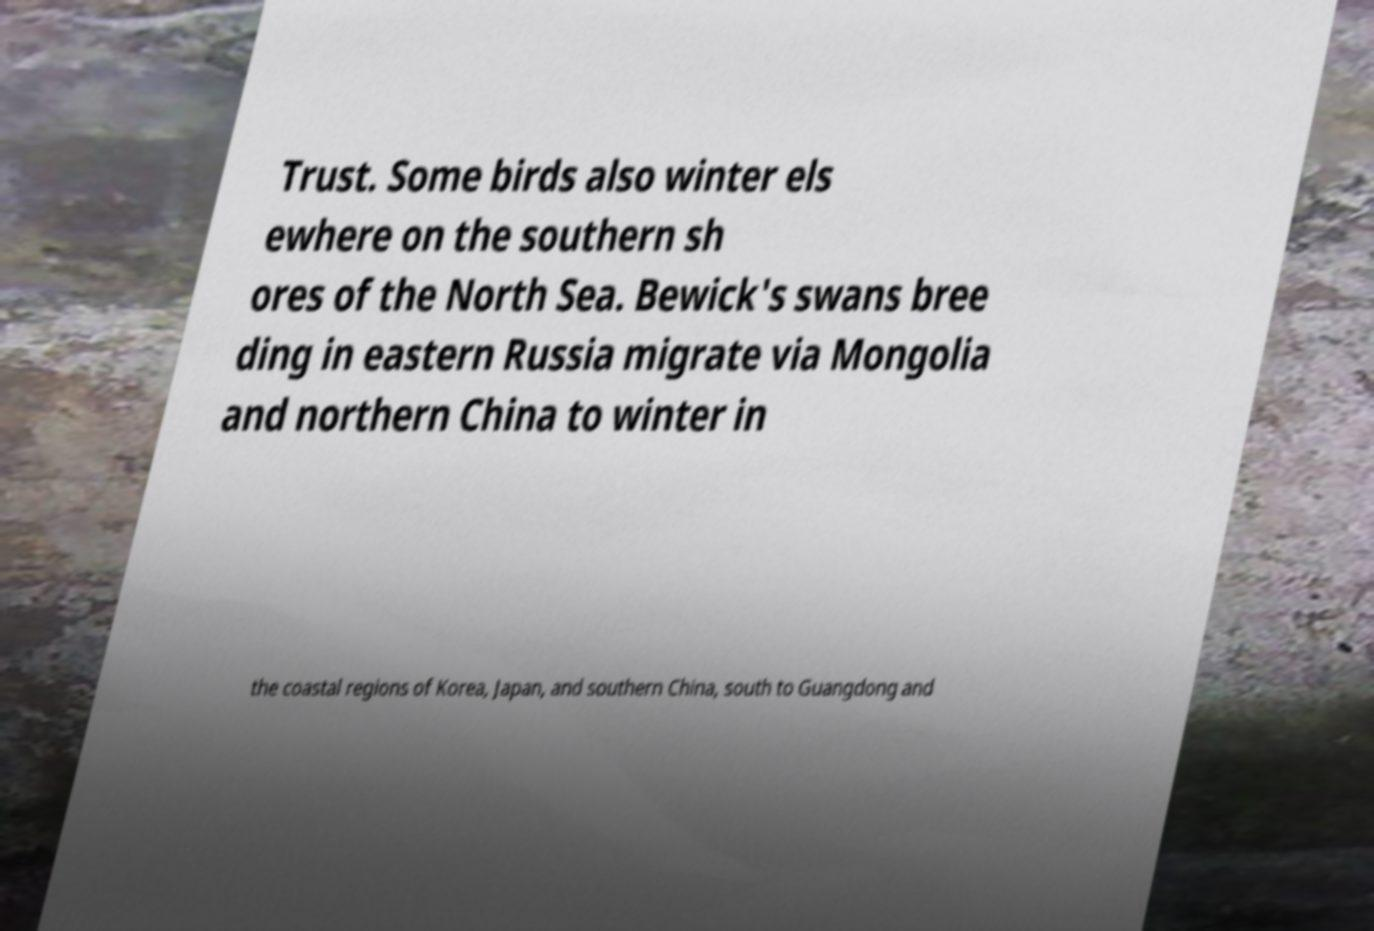What messages or text are displayed in this image? I need them in a readable, typed format. Trust. Some birds also winter els ewhere on the southern sh ores of the North Sea. Bewick's swans bree ding in eastern Russia migrate via Mongolia and northern China to winter in the coastal regions of Korea, Japan, and southern China, south to Guangdong and 